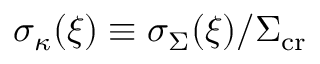Convert formula to latex. <formula><loc_0><loc_0><loc_500><loc_500>\sigma _ { \kappa } ( \xi ) \equiv \sigma _ { \Sigma } ( \xi ) / \Sigma _ { c r }</formula> 